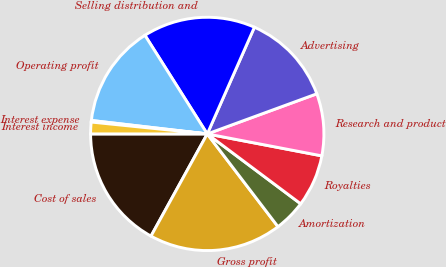Convert chart to OTSL. <chart><loc_0><loc_0><loc_500><loc_500><pie_chart><fcel>Cost of sales<fcel>Gross profit<fcel>Amortization<fcel>Royalties<fcel>Research and product<fcel>Advertising<fcel>Selling distribution and<fcel>Operating profit<fcel>Interest expense<fcel>Interest income<nl><fcel>16.99%<fcel>18.38%<fcel>4.41%<fcel>7.21%<fcel>8.6%<fcel>12.79%<fcel>15.59%<fcel>14.19%<fcel>0.22%<fcel>1.62%<nl></chart> 